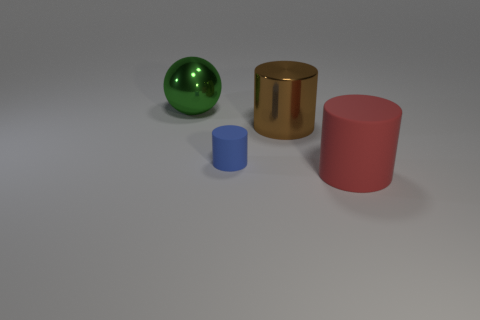Subtract all gray balls. Subtract all blue cubes. How many balls are left? 1 Add 4 large spheres. How many objects exist? 8 Subtract all cylinders. How many objects are left? 1 Add 2 big red matte cylinders. How many big red matte cylinders are left? 3 Add 1 brown metal balls. How many brown metal balls exist? 1 Subtract 1 blue cylinders. How many objects are left? 3 Subtract all big red rubber cylinders. Subtract all big metallic objects. How many objects are left? 1 